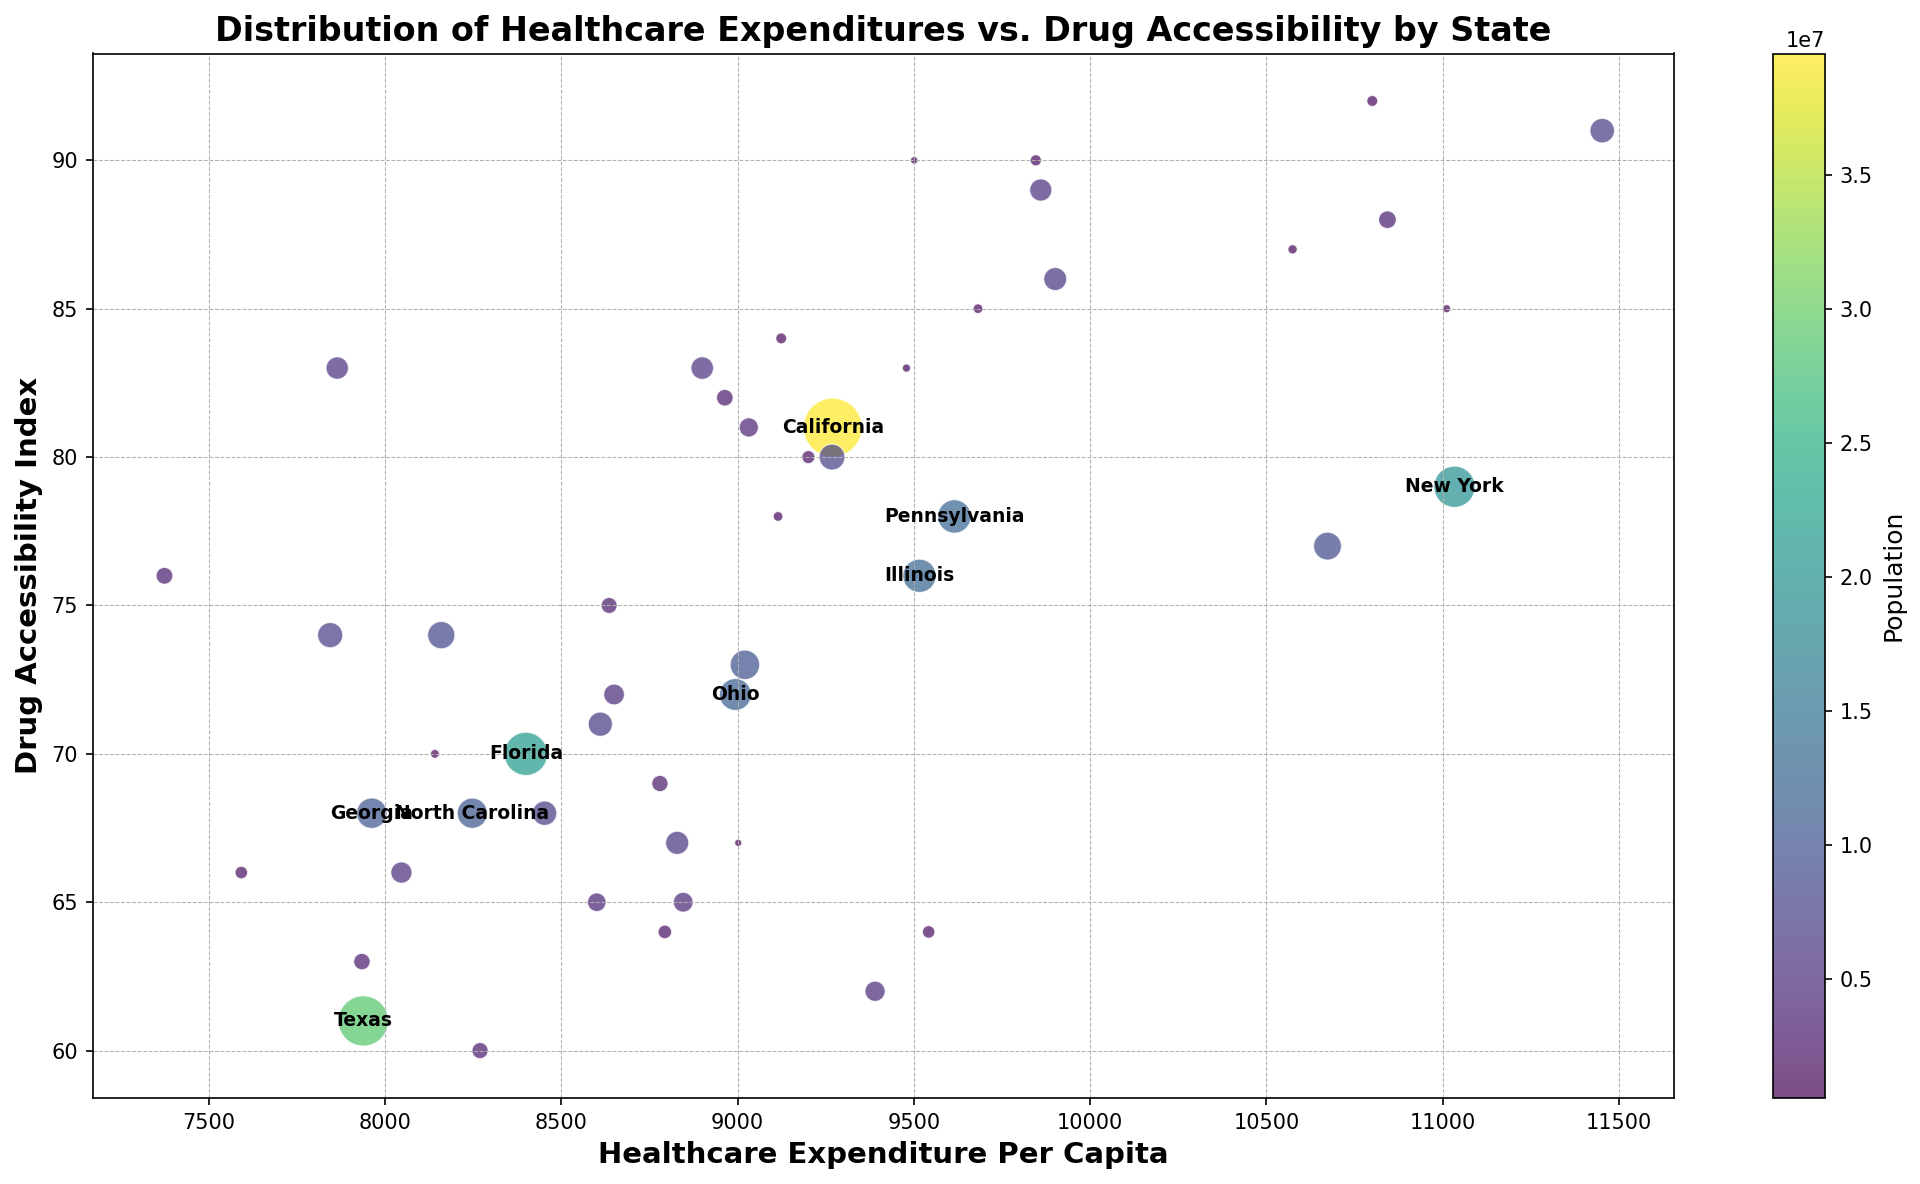Which state has the highest drug accessibility index? To find the state with the highest drug accessibility index, look for the bubble positioned highest on the y-axis. Massachusetts is at the top with a drug accessibility index of 91.
Answer: Massachusetts What is the healthcare expenditure per capita for the state with the largest population? The state with the largest population has the largest-sized bubble. California has the largest bubble, so we check the x-axis value corresponding to California's bubble which is approximately 9270.
Answer: 9270 Does higher healthcare expenditure correlate with better drug accessibility? To determine this, observe the general trend of the bubbles along the x-axis (healthcare expenditure) and y-axis (drug accessibility). An inspection suggests that states with higher expenditure tend to have higher accessibility, indicating a trend.
Answer: Yes Which state has a healthcare expenditure per capita close to 9000 but a relatively low drug accessibility index? Look for bubbles around 9000 on the x-axis and scan for those positioned lower on the y-axis. Wyoming has an expenditure of 9002 and a drug accessibility index of 67, which fits the criteria.
Answer: Wyoming For states with a population over 10 million, is there a consistent relationship between healthcare expenditure and drug accessibility? The large bubbles are annotated with state names. Compare their positions. States like California, Texas, Florida, and New York show varied drug accessibility indices despite their high populations and varied expenditures, indicating no consistent relationship.
Answer: No Which states have a drug accessibility index below 70 and healthcare expenditure above 9000? Identify bubbles below 70 on the y-axis and to the right of 9000 on the x-axis. West Virginia (expenditure 9542, accessibility 64) and Louisiana (expenditure 9390, accessibility 62) fit these criteria.
Answer: West Virginia, Louisiana What is the approximate range of healthcare expenditure per capita for states with an accessibility index above 80? Observe bubbles above the 80 mark on the y-axis and note their x-axis range. The expenditure range starts around 7865 (Colorado) and extends to 11452 (Massachusetts).
Answer: 7865 - 11452 